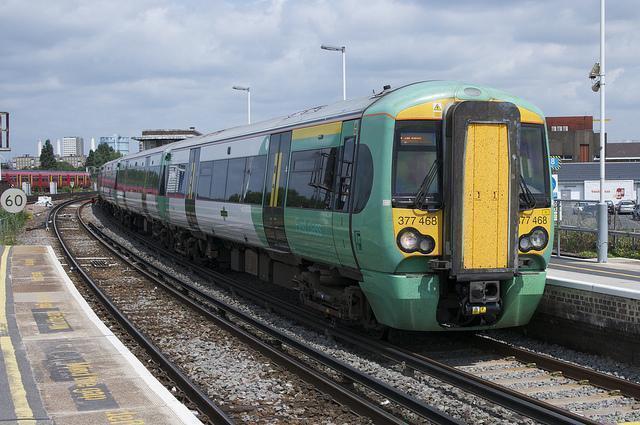What are the black poles on the front train window?
Select the accurate answer and provide justification: `Answer: choice
Rationale: srationale.`
Options: Wipers, antennae, handles, bumpers. Answer: wipers.
Rationale: The poles are wipers. 